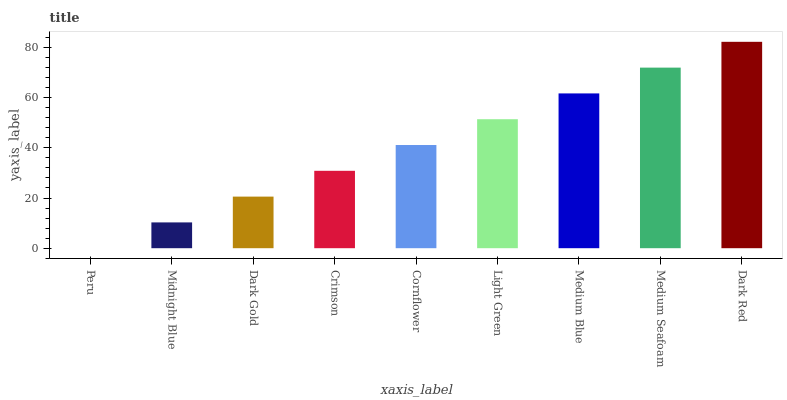Is Peru the minimum?
Answer yes or no. Yes. Is Dark Red the maximum?
Answer yes or no. Yes. Is Midnight Blue the minimum?
Answer yes or no. No. Is Midnight Blue the maximum?
Answer yes or no. No. Is Midnight Blue greater than Peru?
Answer yes or no. Yes. Is Peru less than Midnight Blue?
Answer yes or no. Yes. Is Peru greater than Midnight Blue?
Answer yes or no. No. Is Midnight Blue less than Peru?
Answer yes or no. No. Is Cornflower the high median?
Answer yes or no. Yes. Is Cornflower the low median?
Answer yes or no. Yes. Is Medium Seafoam the high median?
Answer yes or no. No. Is Medium Seafoam the low median?
Answer yes or no. No. 